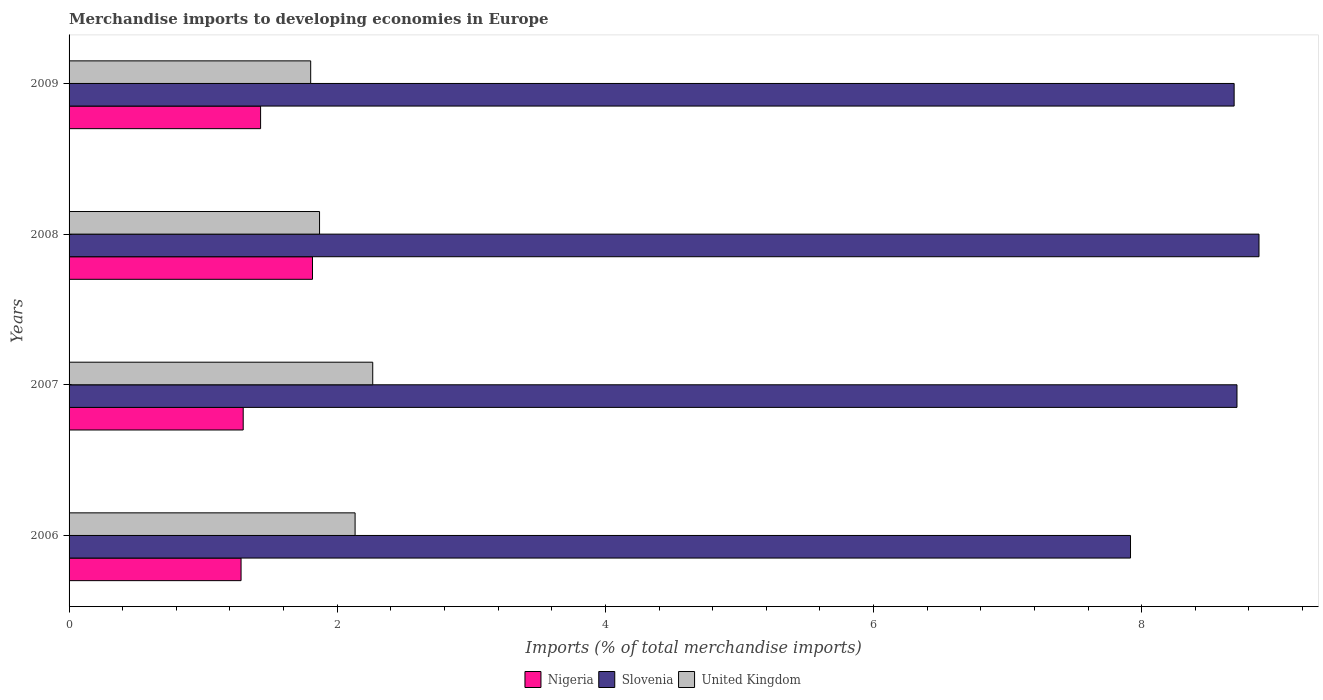How many different coloured bars are there?
Your answer should be very brief. 3. Are the number of bars on each tick of the Y-axis equal?
Your response must be concise. Yes. What is the label of the 1st group of bars from the top?
Your answer should be compact. 2009. In how many cases, is the number of bars for a given year not equal to the number of legend labels?
Your response must be concise. 0. What is the percentage total merchandise imports in Slovenia in 2009?
Provide a succinct answer. 8.69. Across all years, what is the maximum percentage total merchandise imports in United Kingdom?
Your answer should be compact. 2.26. Across all years, what is the minimum percentage total merchandise imports in Slovenia?
Your answer should be compact. 7.92. In which year was the percentage total merchandise imports in United Kingdom maximum?
Your response must be concise. 2007. What is the total percentage total merchandise imports in United Kingdom in the graph?
Your answer should be very brief. 8.07. What is the difference between the percentage total merchandise imports in United Kingdom in 2008 and that in 2009?
Offer a terse response. 0.07. What is the difference between the percentage total merchandise imports in United Kingdom in 2006 and the percentage total merchandise imports in Slovenia in 2007?
Offer a terse response. -6.58. What is the average percentage total merchandise imports in United Kingdom per year?
Give a very brief answer. 2.02. In the year 2007, what is the difference between the percentage total merchandise imports in Slovenia and percentage total merchandise imports in Nigeria?
Offer a terse response. 7.41. What is the ratio of the percentage total merchandise imports in Slovenia in 2007 to that in 2009?
Keep it short and to the point. 1. What is the difference between the highest and the second highest percentage total merchandise imports in Slovenia?
Offer a very short reply. 0.16. What is the difference between the highest and the lowest percentage total merchandise imports in Slovenia?
Make the answer very short. 0.96. Is the sum of the percentage total merchandise imports in Nigeria in 2007 and 2008 greater than the maximum percentage total merchandise imports in Slovenia across all years?
Make the answer very short. No. What does the 3rd bar from the top in 2007 represents?
Your response must be concise. Nigeria. What does the 3rd bar from the bottom in 2008 represents?
Keep it short and to the point. United Kingdom. Are all the bars in the graph horizontal?
Your answer should be compact. Yes. What is the difference between two consecutive major ticks on the X-axis?
Your answer should be very brief. 2. Does the graph contain grids?
Ensure brevity in your answer.  No. Where does the legend appear in the graph?
Give a very brief answer. Bottom center. How many legend labels are there?
Ensure brevity in your answer.  3. What is the title of the graph?
Provide a succinct answer. Merchandise imports to developing economies in Europe. Does "Ghana" appear as one of the legend labels in the graph?
Your answer should be compact. No. What is the label or title of the X-axis?
Give a very brief answer. Imports (% of total merchandise imports). What is the label or title of the Y-axis?
Make the answer very short. Years. What is the Imports (% of total merchandise imports) in Nigeria in 2006?
Ensure brevity in your answer.  1.28. What is the Imports (% of total merchandise imports) of Slovenia in 2006?
Your answer should be compact. 7.92. What is the Imports (% of total merchandise imports) in United Kingdom in 2006?
Make the answer very short. 2.13. What is the Imports (% of total merchandise imports) of Nigeria in 2007?
Make the answer very short. 1.3. What is the Imports (% of total merchandise imports) of Slovenia in 2007?
Provide a short and direct response. 8.71. What is the Imports (% of total merchandise imports) of United Kingdom in 2007?
Your answer should be compact. 2.26. What is the Imports (% of total merchandise imports) of Nigeria in 2008?
Offer a terse response. 1.82. What is the Imports (% of total merchandise imports) of Slovenia in 2008?
Ensure brevity in your answer.  8.88. What is the Imports (% of total merchandise imports) of United Kingdom in 2008?
Offer a very short reply. 1.87. What is the Imports (% of total merchandise imports) in Nigeria in 2009?
Ensure brevity in your answer.  1.43. What is the Imports (% of total merchandise imports) of Slovenia in 2009?
Provide a short and direct response. 8.69. What is the Imports (% of total merchandise imports) of United Kingdom in 2009?
Give a very brief answer. 1.8. Across all years, what is the maximum Imports (% of total merchandise imports) in Nigeria?
Offer a terse response. 1.82. Across all years, what is the maximum Imports (% of total merchandise imports) in Slovenia?
Make the answer very short. 8.88. Across all years, what is the maximum Imports (% of total merchandise imports) in United Kingdom?
Offer a terse response. 2.26. Across all years, what is the minimum Imports (% of total merchandise imports) of Nigeria?
Ensure brevity in your answer.  1.28. Across all years, what is the minimum Imports (% of total merchandise imports) in Slovenia?
Keep it short and to the point. 7.92. Across all years, what is the minimum Imports (% of total merchandise imports) of United Kingdom?
Offer a terse response. 1.8. What is the total Imports (% of total merchandise imports) in Nigeria in the graph?
Keep it short and to the point. 5.83. What is the total Imports (% of total merchandise imports) in Slovenia in the graph?
Provide a short and direct response. 34.19. What is the total Imports (% of total merchandise imports) of United Kingdom in the graph?
Give a very brief answer. 8.07. What is the difference between the Imports (% of total merchandise imports) of Nigeria in 2006 and that in 2007?
Give a very brief answer. -0.02. What is the difference between the Imports (% of total merchandise imports) in Slovenia in 2006 and that in 2007?
Your answer should be compact. -0.79. What is the difference between the Imports (% of total merchandise imports) of United Kingdom in 2006 and that in 2007?
Your answer should be compact. -0.13. What is the difference between the Imports (% of total merchandise imports) in Nigeria in 2006 and that in 2008?
Your answer should be very brief. -0.53. What is the difference between the Imports (% of total merchandise imports) in Slovenia in 2006 and that in 2008?
Ensure brevity in your answer.  -0.96. What is the difference between the Imports (% of total merchandise imports) of United Kingdom in 2006 and that in 2008?
Give a very brief answer. 0.27. What is the difference between the Imports (% of total merchandise imports) in Nigeria in 2006 and that in 2009?
Offer a terse response. -0.15. What is the difference between the Imports (% of total merchandise imports) of Slovenia in 2006 and that in 2009?
Keep it short and to the point. -0.77. What is the difference between the Imports (% of total merchandise imports) in United Kingdom in 2006 and that in 2009?
Ensure brevity in your answer.  0.33. What is the difference between the Imports (% of total merchandise imports) in Nigeria in 2007 and that in 2008?
Offer a terse response. -0.52. What is the difference between the Imports (% of total merchandise imports) in Slovenia in 2007 and that in 2008?
Give a very brief answer. -0.16. What is the difference between the Imports (% of total merchandise imports) of United Kingdom in 2007 and that in 2008?
Keep it short and to the point. 0.4. What is the difference between the Imports (% of total merchandise imports) of Nigeria in 2007 and that in 2009?
Provide a short and direct response. -0.13. What is the difference between the Imports (% of total merchandise imports) in Slovenia in 2007 and that in 2009?
Offer a terse response. 0.02. What is the difference between the Imports (% of total merchandise imports) of United Kingdom in 2007 and that in 2009?
Your answer should be very brief. 0.46. What is the difference between the Imports (% of total merchandise imports) in Nigeria in 2008 and that in 2009?
Give a very brief answer. 0.39. What is the difference between the Imports (% of total merchandise imports) of Slovenia in 2008 and that in 2009?
Provide a short and direct response. 0.19. What is the difference between the Imports (% of total merchandise imports) of United Kingdom in 2008 and that in 2009?
Make the answer very short. 0.07. What is the difference between the Imports (% of total merchandise imports) of Nigeria in 2006 and the Imports (% of total merchandise imports) of Slovenia in 2007?
Provide a succinct answer. -7.43. What is the difference between the Imports (% of total merchandise imports) of Nigeria in 2006 and the Imports (% of total merchandise imports) of United Kingdom in 2007?
Ensure brevity in your answer.  -0.98. What is the difference between the Imports (% of total merchandise imports) in Slovenia in 2006 and the Imports (% of total merchandise imports) in United Kingdom in 2007?
Your answer should be very brief. 5.65. What is the difference between the Imports (% of total merchandise imports) in Nigeria in 2006 and the Imports (% of total merchandise imports) in Slovenia in 2008?
Offer a very short reply. -7.59. What is the difference between the Imports (% of total merchandise imports) of Nigeria in 2006 and the Imports (% of total merchandise imports) of United Kingdom in 2008?
Give a very brief answer. -0.59. What is the difference between the Imports (% of total merchandise imports) of Slovenia in 2006 and the Imports (% of total merchandise imports) of United Kingdom in 2008?
Your answer should be very brief. 6.05. What is the difference between the Imports (% of total merchandise imports) of Nigeria in 2006 and the Imports (% of total merchandise imports) of Slovenia in 2009?
Your answer should be very brief. -7.41. What is the difference between the Imports (% of total merchandise imports) of Nigeria in 2006 and the Imports (% of total merchandise imports) of United Kingdom in 2009?
Offer a very short reply. -0.52. What is the difference between the Imports (% of total merchandise imports) in Slovenia in 2006 and the Imports (% of total merchandise imports) in United Kingdom in 2009?
Keep it short and to the point. 6.11. What is the difference between the Imports (% of total merchandise imports) in Nigeria in 2007 and the Imports (% of total merchandise imports) in Slovenia in 2008?
Make the answer very short. -7.58. What is the difference between the Imports (% of total merchandise imports) of Nigeria in 2007 and the Imports (% of total merchandise imports) of United Kingdom in 2008?
Your response must be concise. -0.57. What is the difference between the Imports (% of total merchandise imports) of Slovenia in 2007 and the Imports (% of total merchandise imports) of United Kingdom in 2008?
Offer a very short reply. 6.84. What is the difference between the Imports (% of total merchandise imports) in Nigeria in 2007 and the Imports (% of total merchandise imports) in Slovenia in 2009?
Provide a succinct answer. -7.39. What is the difference between the Imports (% of total merchandise imports) of Nigeria in 2007 and the Imports (% of total merchandise imports) of United Kingdom in 2009?
Give a very brief answer. -0.5. What is the difference between the Imports (% of total merchandise imports) of Slovenia in 2007 and the Imports (% of total merchandise imports) of United Kingdom in 2009?
Offer a very short reply. 6.91. What is the difference between the Imports (% of total merchandise imports) in Nigeria in 2008 and the Imports (% of total merchandise imports) in Slovenia in 2009?
Provide a succinct answer. -6.87. What is the difference between the Imports (% of total merchandise imports) of Nigeria in 2008 and the Imports (% of total merchandise imports) of United Kingdom in 2009?
Your response must be concise. 0.01. What is the difference between the Imports (% of total merchandise imports) of Slovenia in 2008 and the Imports (% of total merchandise imports) of United Kingdom in 2009?
Your response must be concise. 7.07. What is the average Imports (% of total merchandise imports) of Nigeria per year?
Offer a terse response. 1.46. What is the average Imports (% of total merchandise imports) of Slovenia per year?
Keep it short and to the point. 8.55. What is the average Imports (% of total merchandise imports) in United Kingdom per year?
Your response must be concise. 2.02. In the year 2006, what is the difference between the Imports (% of total merchandise imports) of Nigeria and Imports (% of total merchandise imports) of Slovenia?
Give a very brief answer. -6.63. In the year 2006, what is the difference between the Imports (% of total merchandise imports) of Nigeria and Imports (% of total merchandise imports) of United Kingdom?
Provide a short and direct response. -0.85. In the year 2006, what is the difference between the Imports (% of total merchandise imports) of Slovenia and Imports (% of total merchandise imports) of United Kingdom?
Offer a very short reply. 5.78. In the year 2007, what is the difference between the Imports (% of total merchandise imports) in Nigeria and Imports (% of total merchandise imports) in Slovenia?
Your answer should be very brief. -7.41. In the year 2007, what is the difference between the Imports (% of total merchandise imports) in Nigeria and Imports (% of total merchandise imports) in United Kingdom?
Provide a short and direct response. -0.97. In the year 2007, what is the difference between the Imports (% of total merchandise imports) of Slovenia and Imports (% of total merchandise imports) of United Kingdom?
Provide a short and direct response. 6.45. In the year 2008, what is the difference between the Imports (% of total merchandise imports) of Nigeria and Imports (% of total merchandise imports) of Slovenia?
Provide a short and direct response. -7.06. In the year 2008, what is the difference between the Imports (% of total merchandise imports) of Nigeria and Imports (% of total merchandise imports) of United Kingdom?
Ensure brevity in your answer.  -0.05. In the year 2008, what is the difference between the Imports (% of total merchandise imports) in Slovenia and Imports (% of total merchandise imports) in United Kingdom?
Make the answer very short. 7.01. In the year 2009, what is the difference between the Imports (% of total merchandise imports) in Nigeria and Imports (% of total merchandise imports) in Slovenia?
Offer a terse response. -7.26. In the year 2009, what is the difference between the Imports (% of total merchandise imports) in Nigeria and Imports (% of total merchandise imports) in United Kingdom?
Your answer should be compact. -0.37. In the year 2009, what is the difference between the Imports (% of total merchandise imports) of Slovenia and Imports (% of total merchandise imports) of United Kingdom?
Make the answer very short. 6.89. What is the ratio of the Imports (% of total merchandise imports) in Nigeria in 2006 to that in 2007?
Make the answer very short. 0.99. What is the ratio of the Imports (% of total merchandise imports) of Slovenia in 2006 to that in 2007?
Your answer should be compact. 0.91. What is the ratio of the Imports (% of total merchandise imports) in United Kingdom in 2006 to that in 2007?
Provide a succinct answer. 0.94. What is the ratio of the Imports (% of total merchandise imports) of Nigeria in 2006 to that in 2008?
Provide a short and direct response. 0.71. What is the ratio of the Imports (% of total merchandise imports) in Slovenia in 2006 to that in 2008?
Provide a short and direct response. 0.89. What is the ratio of the Imports (% of total merchandise imports) of United Kingdom in 2006 to that in 2008?
Provide a succinct answer. 1.14. What is the ratio of the Imports (% of total merchandise imports) of Nigeria in 2006 to that in 2009?
Your answer should be very brief. 0.9. What is the ratio of the Imports (% of total merchandise imports) in Slovenia in 2006 to that in 2009?
Give a very brief answer. 0.91. What is the ratio of the Imports (% of total merchandise imports) of United Kingdom in 2006 to that in 2009?
Make the answer very short. 1.18. What is the ratio of the Imports (% of total merchandise imports) in Nigeria in 2007 to that in 2008?
Ensure brevity in your answer.  0.72. What is the ratio of the Imports (% of total merchandise imports) in Slovenia in 2007 to that in 2008?
Keep it short and to the point. 0.98. What is the ratio of the Imports (% of total merchandise imports) in United Kingdom in 2007 to that in 2008?
Ensure brevity in your answer.  1.21. What is the ratio of the Imports (% of total merchandise imports) of Nigeria in 2007 to that in 2009?
Make the answer very short. 0.91. What is the ratio of the Imports (% of total merchandise imports) of United Kingdom in 2007 to that in 2009?
Provide a succinct answer. 1.26. What is the ratio of the Imports (% of total merchandise imports) in Nigeria in 2008 to that in 2009?
Ensure brevity in your answer.  1.27. What is the ratio of the Imports (% of total merchandise imports) of Slovenia in 2008 to that in 2009?
Offer a terse response. 1.02. What is the ratio of the Imports (% of total merchandise imports) in United Kingdom in 2008 to that in 2009?
Ensure brevity in your answer.  1.04. What is the difference between the highest and the second highest Imports (% of total merchandise imports) in Nigeria?
Provide a succinct answer. 0.39. What is the difference between the highest and the second highest Imports (% of total merchandise imports) of Slovenia?
Make the answer very short. 0.16. What is the difference between the highest and the second highest Imports (% of total merchandise imports) in United Kingdom?
Your answer should be compact. 0.13. What is the difference between the highest and the lowest Imports (% of total merchandise imports) of Nigeria?
Your answer should be very brief. 0.53. What is the difference between the highest and the lowest Imports (% of total merchandise imports) in United Kingdom?
Offer a very short reply. 0.46. 